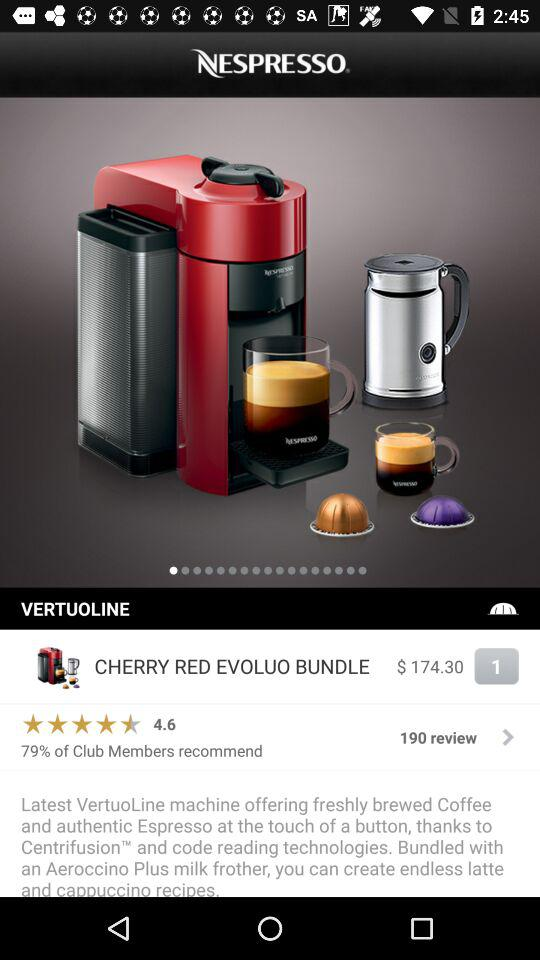What is the rating? The rating is 4.6 stars. 